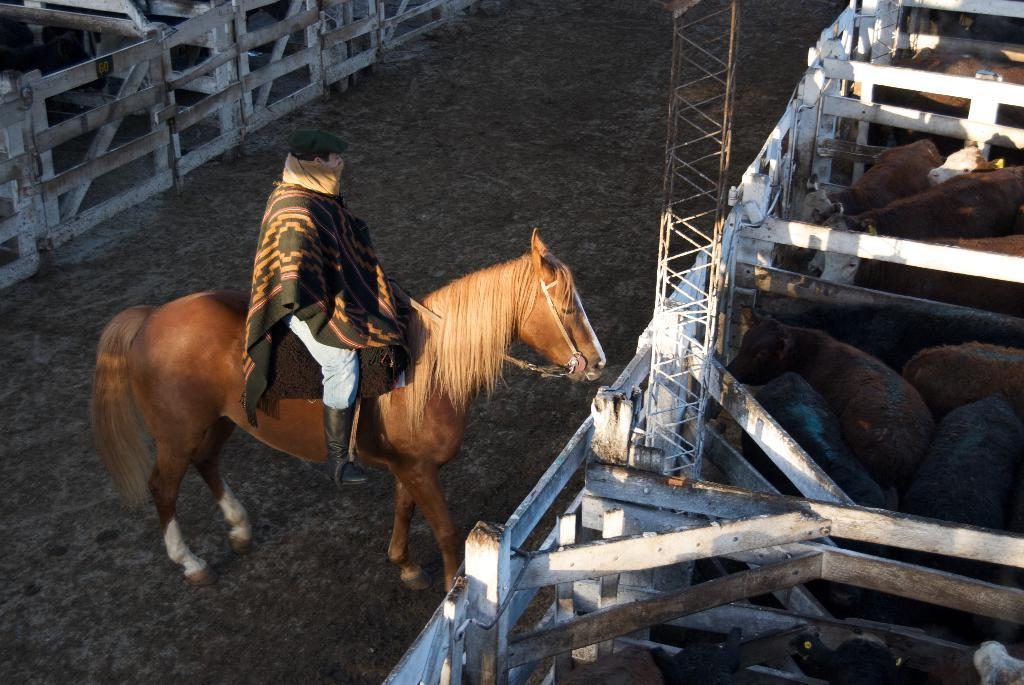What is the main subject of the image? There is a person in the image. What is the person doing in the image? The person is sitting on a horse. Are there any other animals present in the image besides the horse? Yes, there are cows in the image. What type of glue is being used to hold the sticks together in the image? There is no glue or sticks present in the image; it features a person sitting on a horse and cows in the background. What type of plane can be seen flying in the image? There is no plane present in the image. 